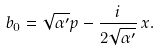Convert formula to latex. <formula><loc_0><loc_0><loc_500><loc_500>b _ { 0 } = \sqrt { \alpha ^ { \prime } } p - \frac { i } { 2 \sqrt { \alpha ^ { \prime } } } \, x .</formula> 